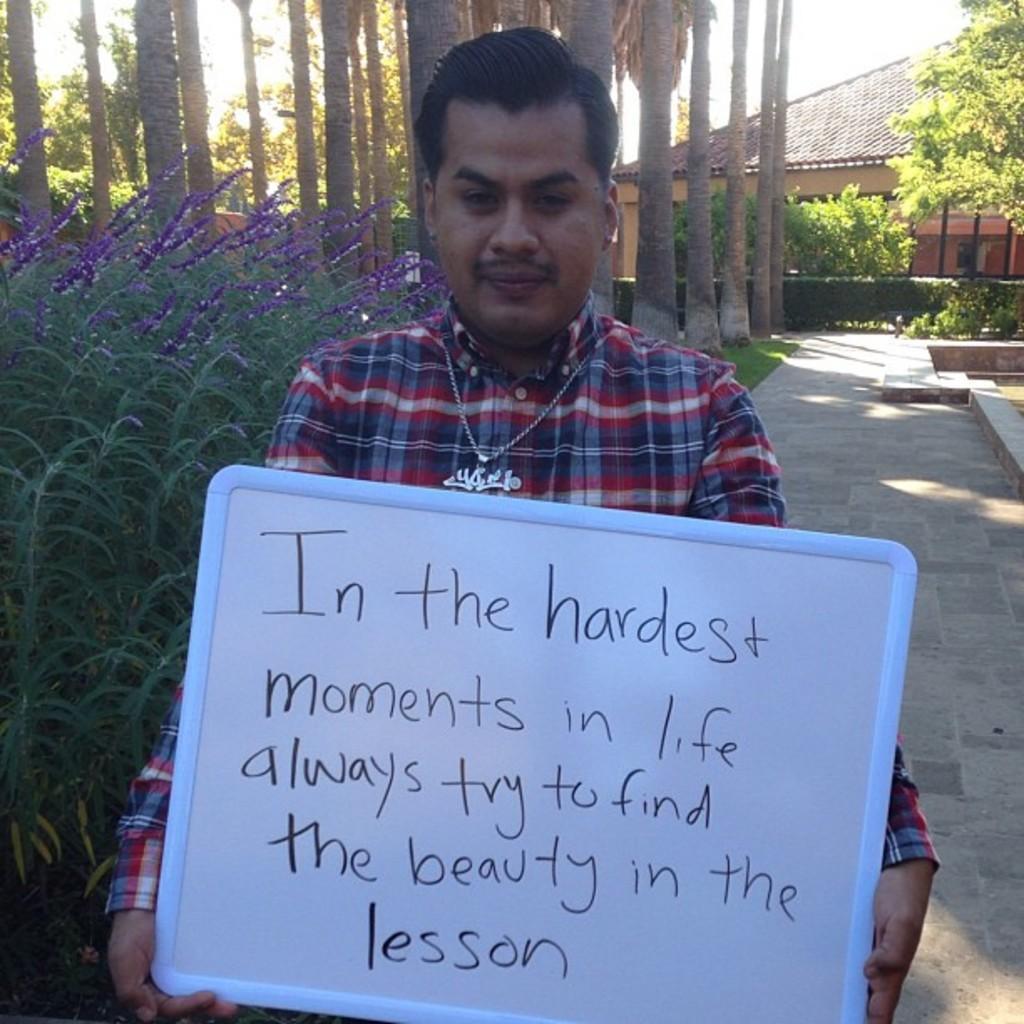Could you give a brief overview of what you see in this image? In the center of the image we can see a man is standing and holding a board. On the board we can see the text. In the background of the image we can see the trees, house, roof, plants, flowers, grass. On the right side of the image we can see the pavement. At the top of the image we can see the sky. 